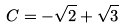<formula> <loc_0><loc_0><loc_500><loc_500>C = - \sqrt { 2 } + \sqrt { 3 }</formula> 